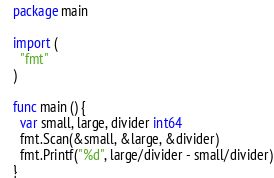<code> <loc_0><loc_0><loc_500><loc_500><_Go_>package main
 
import (
  "fmt"
)
 
func main () {
  var small, large, divider int64
  fmt.Scan(&small, &large, &divider)
  fmt.Printf("%d", large/divider - small/divider)
}</code> 